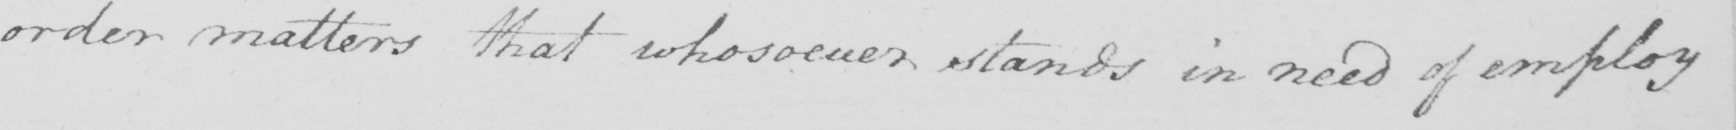What is written in this line of handwriting? order matters that whosoever stands in need of employ 